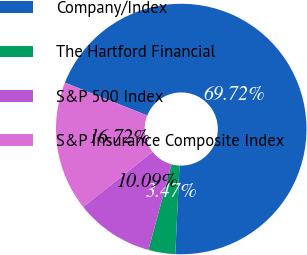Convert chart. <chart><loc_0><loc_0><loc_500><loc_500><pie_chart><fcel>Company/Index<fcel>The Hartford Financial<fcel>S&P 500 Index<fcel>S&P Insurance Composite Index<nl><fcel>69.72%<fcel>3.47%<fcel>10.09%<fcel>16.72%<nl></chart> 